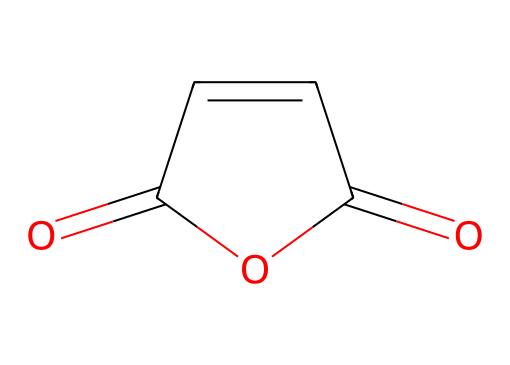how many carbon atoms are in maleic anhydride? The chemical structure shows two carbonyl groups (C=O) and a double bond between two carbon atoms, indicating there are a total of four carbon atoms in the structure.
Answer: four what type of functional groups are present in this compound? The structure exhibits carbonyl groups (C=O) and an anhydride functional group, which is characterized by the presence of two carbonyl groups linked by an oxygen atom.
Answer: carbonyl and anhydride is maleic anhydride an acid or a base? Maleic anhydride typically acts as a Lewis acid due to the presence of electron-deficient carbonyl groups, which can accept electron pairs.
Answer: acid how many double bonds are present in this chemical? Upon analyzing the structure, there is one double bond between the two carbon atoms, and two carbonyl functional groups each denote a double bond as well, leading to a total of three double bonds.
Answer: three what is the molecular formula of maleic anhydride? To derive the molecular formula, count all atoms in the structure: four carbon atoms, two oxygen atoms, and four hydrogen atoms lead to the formula C4H2O3.
Answer: C4H2O3 why is maleic anhydride used in rosin for musical instrument strings? Maleic anhydride offers good adhesion, improves flexibility, and enhances the protective qualities of rosin, making it suitable for application in musical instrument strings, where durability and performance are crucial.
Answer: adhesion and flexibility 